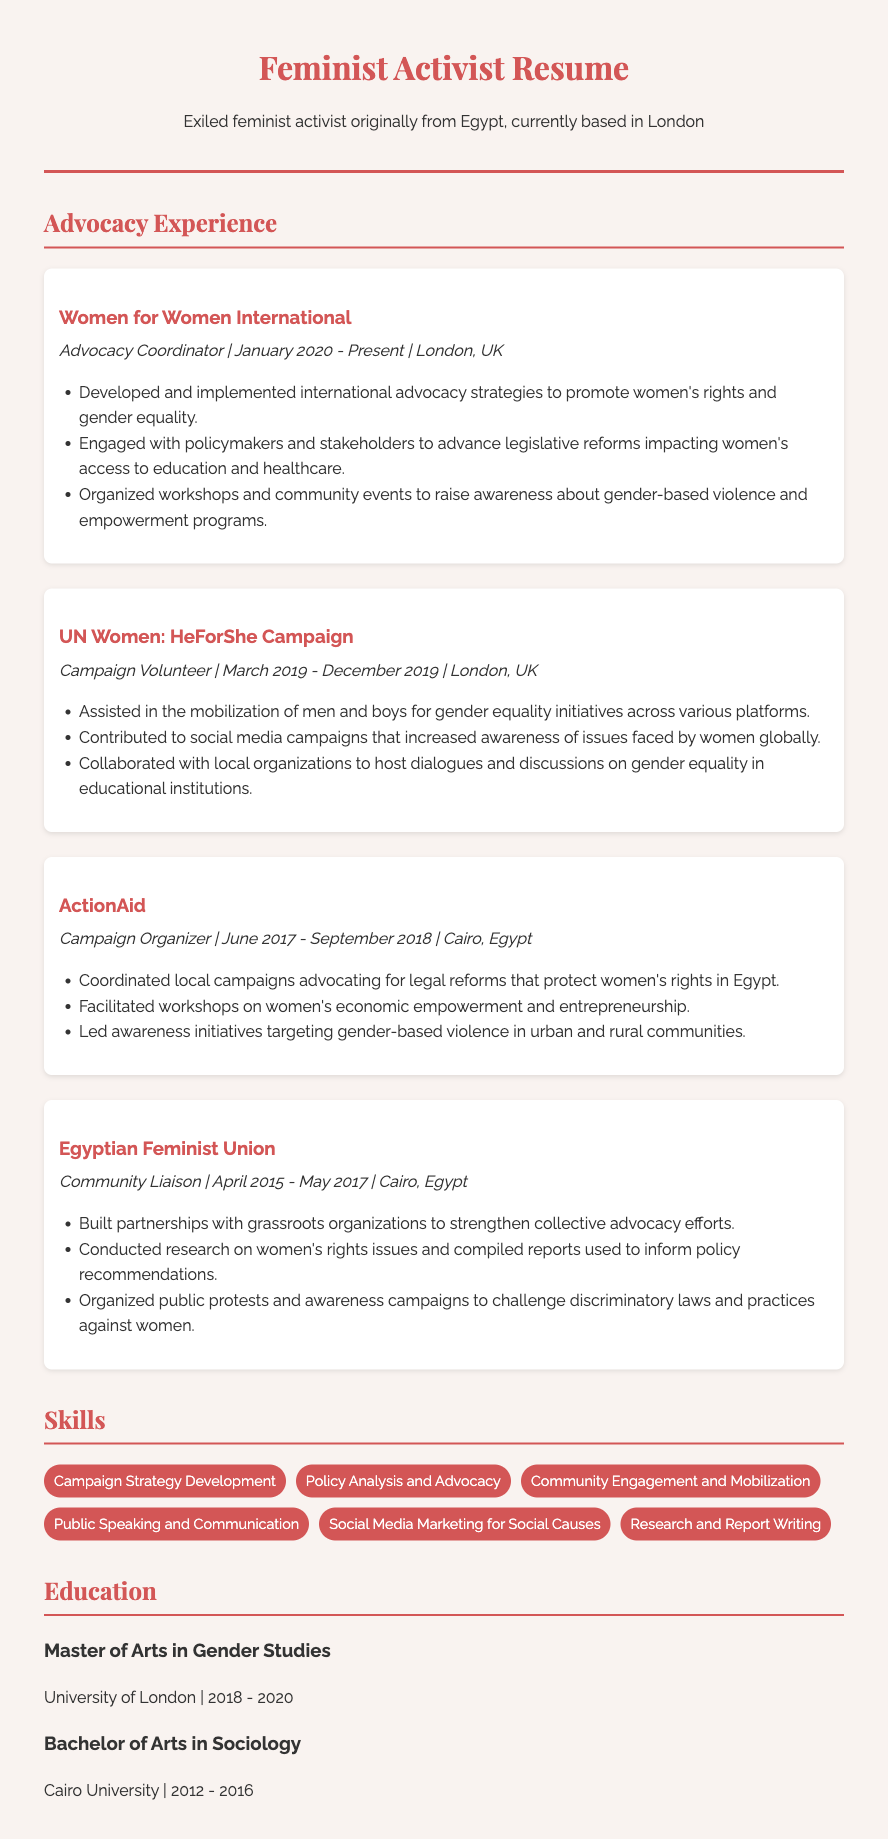What is the current position held? The job title of the current position listed is "Advocacy Coordinator" at Women for Women International.
Answer: Advocacy Coordinator When did the candidate start working at Women for Women International? The starting date for the position is January 2020.
Answer: January 2020 What city is the candidate currently based in? The resume mentions that the candidate is based in London.
Answer: London Which campaign did the candidate volunteer for in 2019? The candidate volunteered for the HeForShe Campaign organized by UN Women.
Answer: HeForShe Campaign What organization did the candidate work for before moving to London? Before London, the candidate worked at ActionAid in Cairo, Egypt.
Answer: ActionAid How long did the candidate serve as a Campaign Organizer? The candidate served as a Campaign Organizer for ActionAid for 15 months, from June 2017 to September 2018.
Answer: 15 months What kind of skills are highlighted in the skills section? The skills section includes "Campaign Strategy Development," among others targeting advocacy.
Answer: Campaign Strategy Development What is the highest educational qualification obtained by the candidate? The highest educational qualification mentioned is a Master of Arts in Gender Studies.
Answer: Master of Arts in Gender Studies Which university did the candidate attend for their undergraduate studies? The undergraduate institution listed is Cairo University.
Answer: Cairo University 